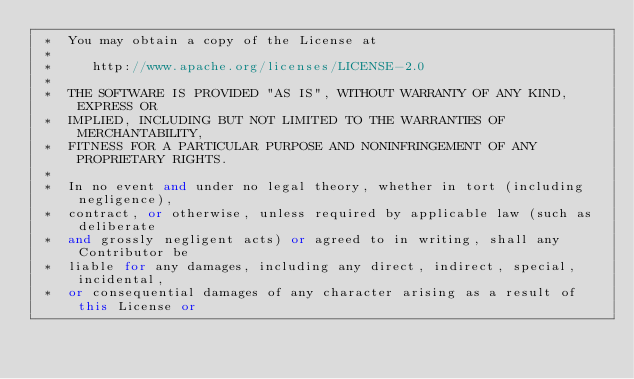<code> <loc_0><loc_0><loc_500><loc_500><_C++_> *  You may obtain a copy of the License at
 * 
 *     http://www.apache.org/licenses/LICENSE-2.0
 * 
 *  THE SOFTWARE IS PROVIDED "AS IS", WITHOUT WARRANTY OF ANY KIND, EXPRESS OR
 *  IMPLIED, INCLUDING BUT NOT LIMITED TO THE WARRANTIES OF MERCHANTABILITY,
 *  FITNESS FOR A PARTICULAR PURPOSE AND NONINFRINGEMENT OF ANY PROPRIETARY RIGHTS.
 *
 *  In no event and under no legal theory, whether in tort (including negligence), 
 *  contract, or otherwise, unless required by applicable law (such as deliberate 
 *  and grossly negligent acts) or agreed to in writing, shall any Contributor be
 *  liable for any damages, including any direct, indirect, special, incidental, 
 *  or consequential damages of any character arising as a result of this License or </code> 